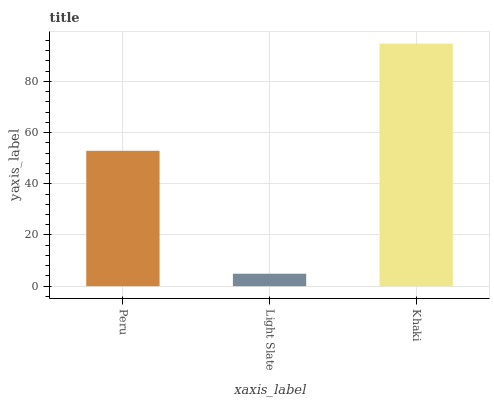Is Light Slate the minimum?
Answer yes or no. Yes. Is Khaki the maximum?
Answer yes or no. Yes. Is Khaki the minimum?
Answer yes or no. No. Is Light Slate the maximum?
Answer yes or no. No. Is Khaki greater than Light Slate?
Answer yes or no. Yes. Is Light Slate less than Khaki?
Answer yes or no. Yes. Is Light Slate greater than Khaki?
Answer yes or no. No. Is Khaki less than Light Slate?
Answer yes or no. No. Is Peru the high median?
Answer yes or no. Yes. Is Peru the low median?
Answer yes or no. Yes. Is Light Slate the high median?
Answer yes or no. No. Is Khaki the low median?
Answer yes or no. No. 